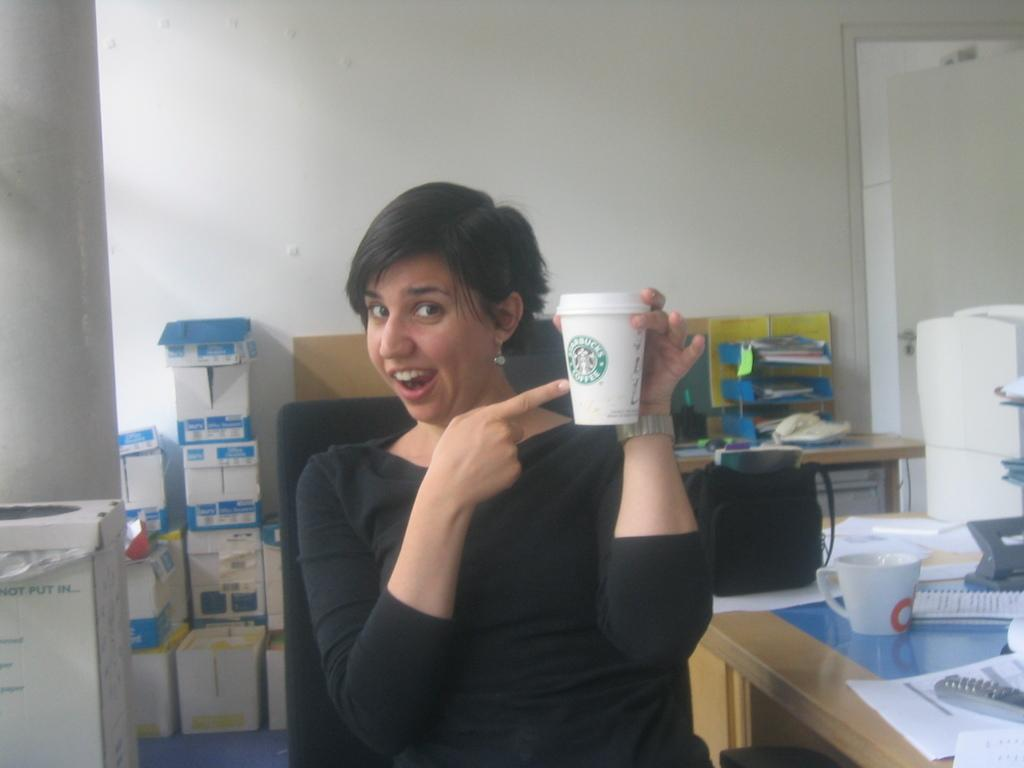What is the color of the wall in the image? The wall in the image is white. What objects can be seen in the image besides the wall? There are boxes, tables, papers, a remote, and cups in the image. How many tables are present in the image? There are tables in the image, but the exact number is not specified. What is placed on the table in the image? Papers, a remote, and cups are placed on the table in the image. What type of whip is being used to steer the ship in the image? There is no whip or ship present in the image; it features a white wall, boxes, tables, papers, a remote, and cups. 